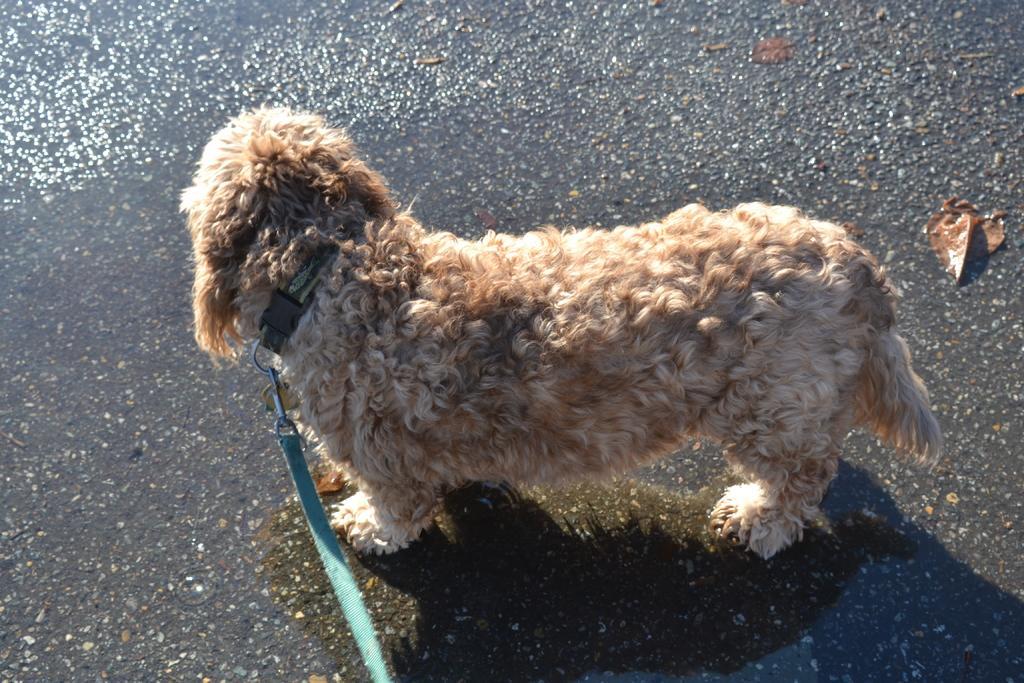How would you summarize this image in a sentence or two? In this image we can see a dog with a leash on the ground. 